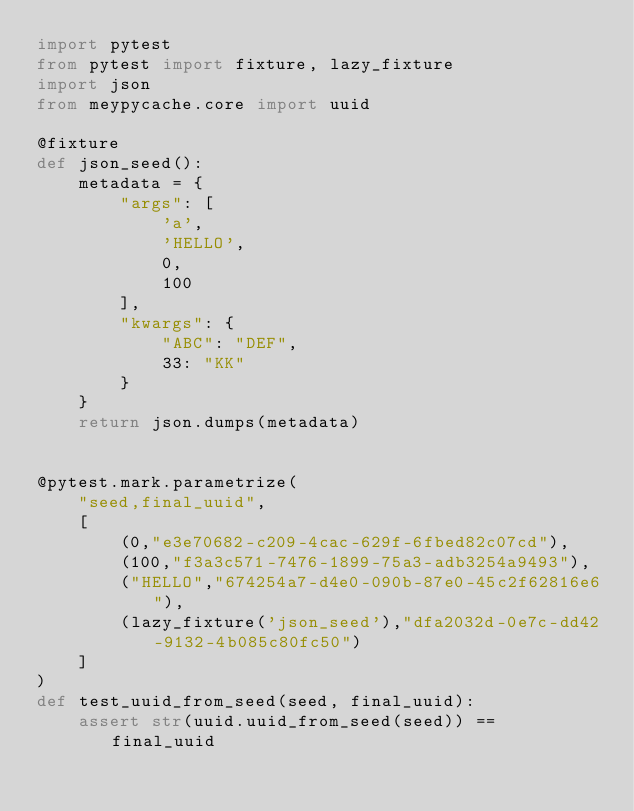<code> <loc_0><loc_0><loc_500><loc_500><_Python_>import pytest
from pytest import fixture, lazy_fixture
import json
from meypycache.core import uuid

@fixture
def json_seed():
    metadata = {
        "args": [
            'a',
            'HELLO',
            0,
            100
        ],
        "kwargs": {
            "ABC": "DEF",
            33: "KK"
        }
    }
    return json.dumps(metadata)


@pytest.mark.parametrize(
    "seed,final_uuid", 
    [
        (0,"e3e70682-c209-4cac-629f-6fbed82c07cd"),
        (100,"f3a3c571-7476-1899-75a3-adb3254a9493"),
        ("HELLO","674254a7-d4e0-090b-87e0-45c2f62816e6"),
        (lazy_fixture('json_seed'),"dfa2032d-0e7c-dd42-9132-4b085c80fc50")
    ]
)
def test_uuid_from_seed(seed, final_uuid):
    assert str(uuid.uuid_from_seed(seed)) == final_uuid
</code> 